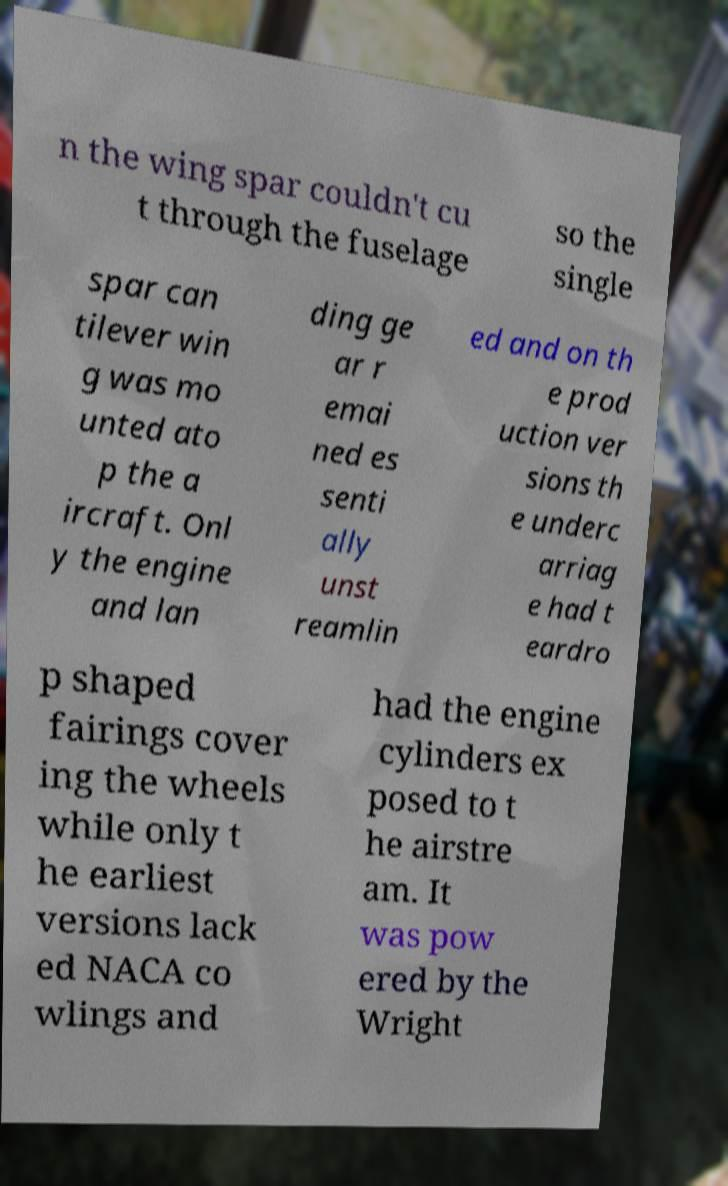Please read and relay the text visible in this image. What does it say? n the wing spar couldn't cu t through the fuselage so the single spar can tilever win g was mo unted ato p the a ircraft. Onl y the engine and lan ding ge ar r emai ned es senti ally unst reamlin ed and on th e prod uction ver sions th e underc arriag e had t eardro p shaped fairings cover ing the wheels while only t he earliest versions lack ed NACA co wlings and had the engine cylinders ex posed to t he airstre am. It was pow ered by the Wright 